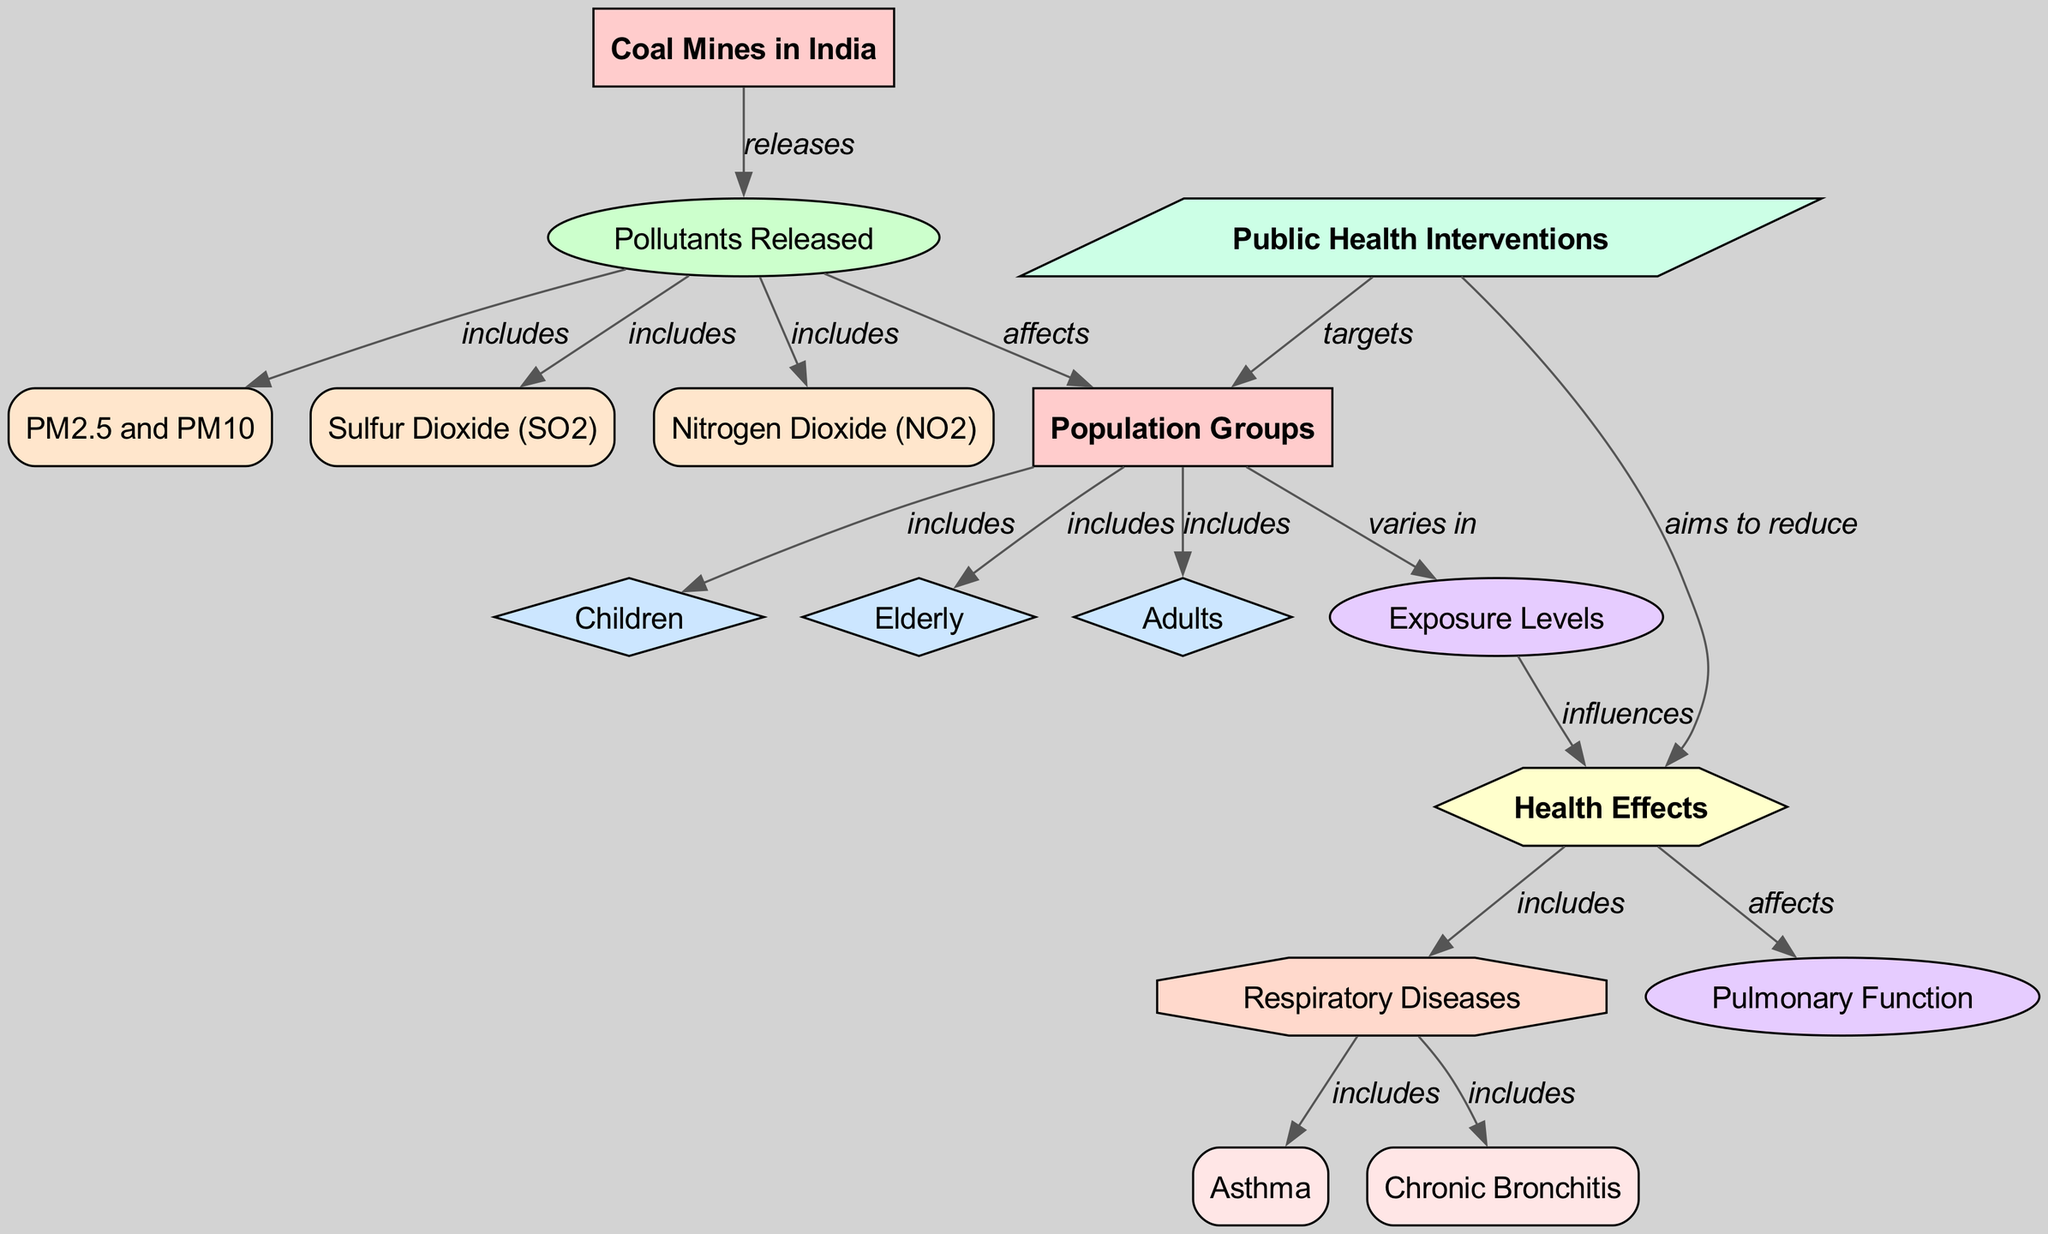What is the main entity represented in the diagram? The main entity in the diagram is "Coal Mines in India," which is the starting point for the flow of information and links to various pollutants and health effects.
Answer: Coal Mines in India How many population groups are indicated in the diagram? The diagram indicates three population groups: Children, Elderly, and Adults, as depicted in the "Population Groups" node that branches into these three specific groups.
Answer: 3 What does the "Pollutants Released" process include? The "Pollutants Released" process includes PM2.5 and PM10, Sulfur Dioxide (SO2), and Nitrogen Dioxide (NO2), which are linked as sub-entities of the pollutants released by coal mines.
Answer: PM2.5, PM10, Sulfur Dioxide, Nitrogen Dioxide Which population group is included under "Population Groups"? The "Population Groups" node includes Children, Elderly, and Adults as represented in the diagram.
Answer: Children, Elderly, Adults What health condition is influenced by exposure levels? Exposure levels influence Health Effects, which includes Respiratory Diseases. This is seen in the flow from "Exposure Levels" to "Health Effects," further detailing "Respiratory Diseases."
Answer: Respiratory Diseases How are public health interventions connected to the population groups? Public health interventions target "Population Groups," indicating that these interventions are designed to address the health effects faced by the communities affected by coal mine pollutants.
Answer: Targets What condition is directly associated with asthma? Asthma is directly associated with Respiratory Diseases, as indicated by the flow from "Health Effects" to "Respiratory Diseases," which includes asthma as a sub-condition.
Answer: Asthma Which pollutant is released by coal mines and is a major health concern? Sulfur Dioxide is one of the pollutants released by coal mines that is indicated as being a significant health concern in the diagram, linked to health outcomes for the populations affected.
Answer: Sulfur Dioxide What is the role of "Public Health Interventions" according to the diagram? The role of "Public Health Interventions" is to aim to reduce the health effects associated with exposure to pollutants found around coal mines in India, targeting both population groups and specific health issues.
Answer: Aims to reduce 